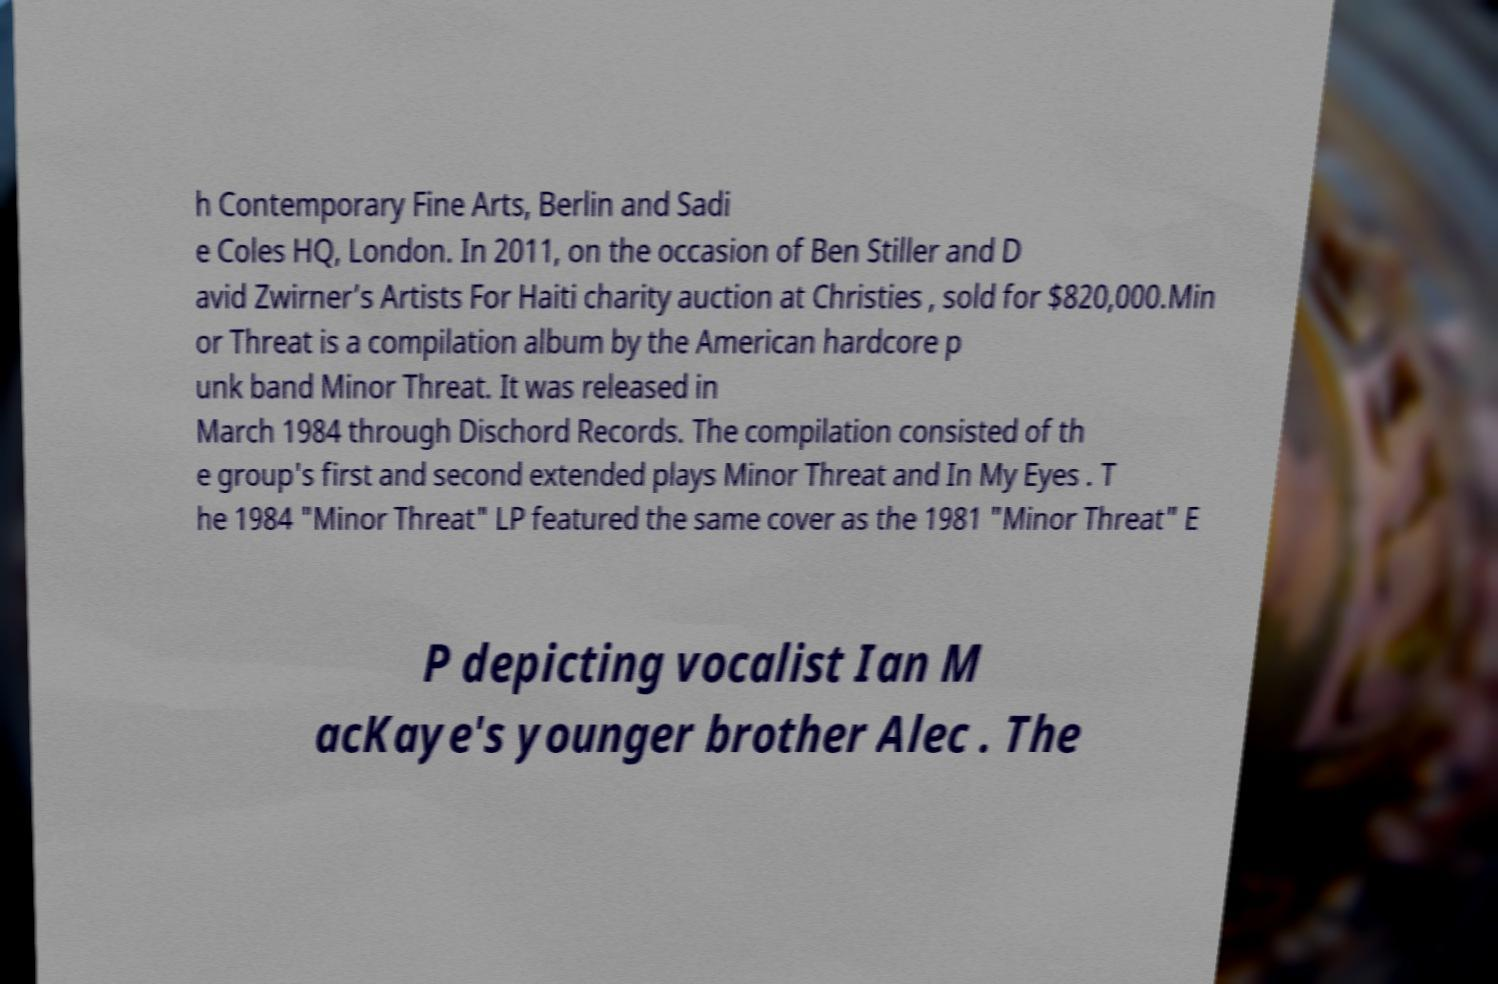Please identify and transcribe the text found in this image. h Contemporary Fine Arts, Berlin and Sadi e Coles HQ, London. In 2011, on the occasion of Ben Stiller and D avid Zwirner’s Artists For Haiti charity auction at Christies , sold for $820,000.Min or Threat is a compilation album by the American hardcore p unk band Minor Threat. It was released in March 1984 through Dischord Records. The compilation consisted of th e group's first and second extended plays Minor Threat and In My Eyes . T he 1984 "Minor Threat" LP featured the same cover as the 1981 "Minor Threat" E P depicting vocalist Ian M acKaye's younger brother Alec . The 